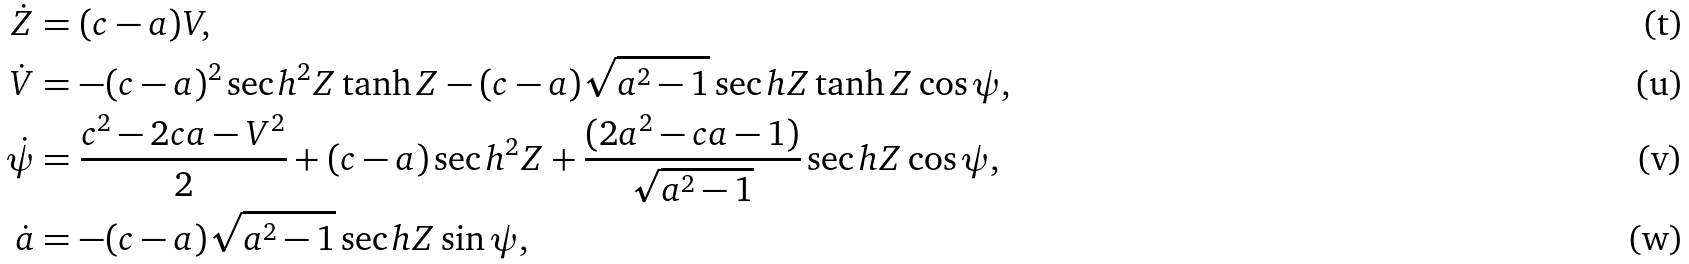Convert formula to latex. <formula><loc_0><loc_0><loc_500><loc_500>\dot { Z } & = ( c - a ) V , \\ \dot { V } & = - ( c - a ) ^ { 2 } \sec h ^ { 2 } { Z } \tanh { Z } - ( c - a ) \sqrt { a ^ { 2 } - 1 } \sec h { Z } \tanh { Z } \cos { \psi } , \\ \dot { \psi } & = \frac { c ^ { 2 } - 2 c a - V ^ { 2 } } { 2 } + ( c - a ) \sec h ^ { 2 } { Z } + \frac { ( 2 a ^ { 2 } - c a - 1 ) } { \sqrt { a ^ { 2 } - 1 } } \sec h { Z } \cos { \psi } , \\ \dot { a } & = - ( c - a ) \sqrt { a ^ { 2 } - 1 } \sec h { Z } \sin { \psi } ,</formula> 